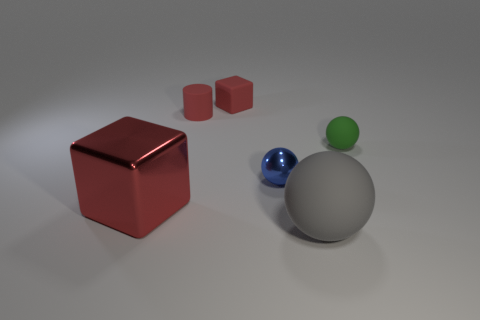The cylinder that is the same color as the big metal cube is what size?
Provide a succinct answer. Small. What number of blue balls are behind the red matte cube?
Provide a short and direct response. 0. Are there the same number of gray balls in front of the gray matte thing and tiny blue spheres on the right side of the blue metallic ball?
Offer a very short reply. Yes. There is a rubber thing in front of the blue sphere; does it have the same shape as the red metallic thing?
Ensure brevity in your answer.  No. Are there any other things that have the same material as the cylinder?
Provide a short and direct response. Yes. There is a gray rubber thing; is its size the same as the metallic object to the right of the small red rubber block?
Offer a very short reply. No. How many other things are the same color as the small rubber cube?
Ensure brevity in your answer.  2. There is a tiny green object; are there any small green spheres on the left side of it?
Make the answer very short. No. What number of things are cyan cubes or metal objects to the right of the tiny red rubber block?
Your answer should be very brief. 1. There is a red rubber thing on the left side of the small red rubber block; are there any red rubber blocks that are in front of it?
Your answer should be compact. No. 